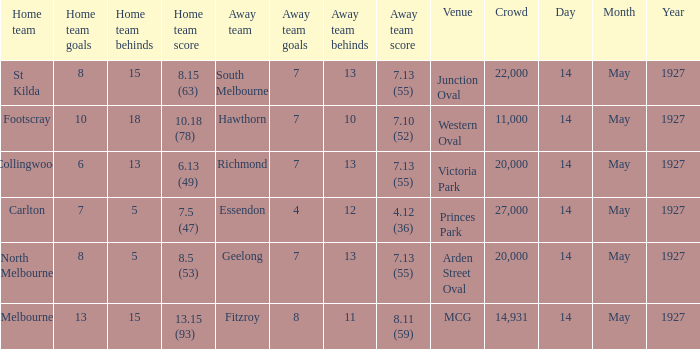Which team was hosting when geelong, as the away team, scored 7.13 (55)? North Melbourne. 